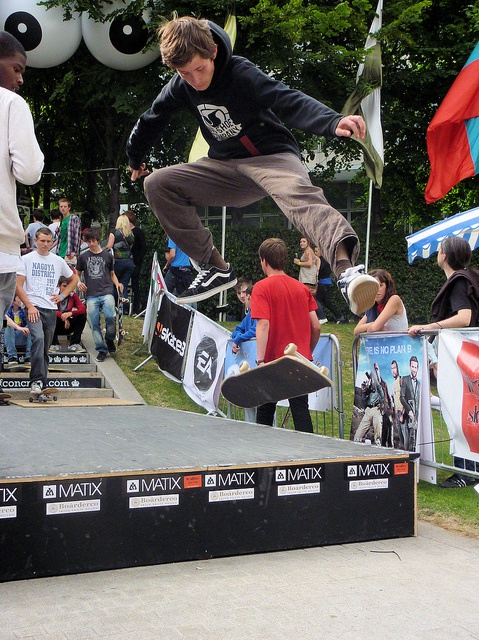Describe the objects in this image and their specific colors. I can see people in darkgray, black, and gray tones, people in darkgray, lightgray, gray, and black tones, people in darkgray, brown, black, and salmon tones, people in darkgray, lavender, black, and gray tones, and skateboard in darkgray, black, lightgray, and gray tones in this image. 